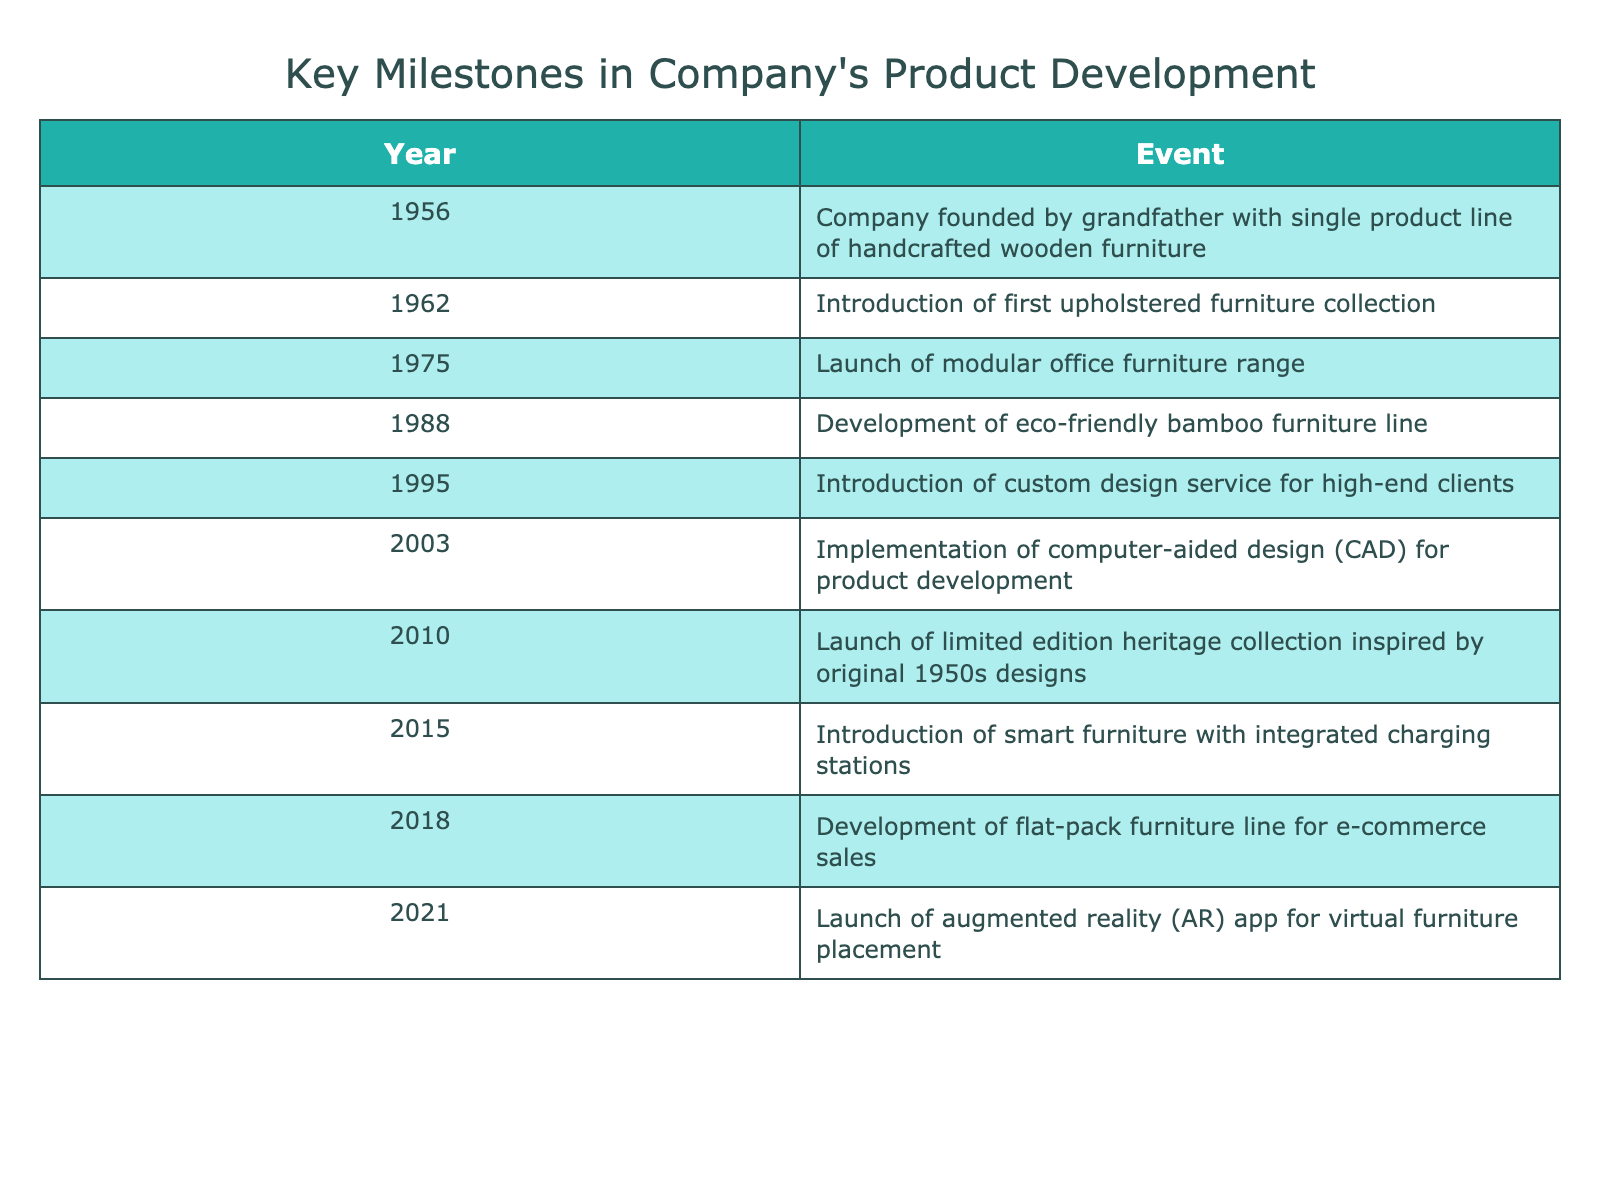What year did the company introduce its first upholstered furniture collection? The table explicitly states that the first upholstered furniture collection was introduced in 1962, as indicated in the "Year" column.
Answer: 1962 How many product lines were launched before the year 2000? The events listed before the year 2000 are: 1956 (founding), 1962 (upholstered collection), 1975 (modular office range), 1988 (bamboo line), 1995 (custom design). This totals to 5 product lines launched before 2000.
Answer: 5 Is the launch of smart furniture in 2015 the first instance of integrating technology in products? The first instance of integrating technology is in 2003 with the implementation of computer-aided design (CAD). Thus, the smart furniture launch is not the first.
Answer: No Which product development event occurred last? The last event in the timeline is the launch of the augmented reality app for virtual furniture placement in 2021, as indicated by the latest year listed in the table.
Answer: 2021 What is the total number of product development milestones listed in the table? By counting all the events from the table, there are a total of 10 milestones from 1956 to 2021.
Answer: 10 What was the primary focus of the product development event in 1988? The 1988 event is focused on the development of an eco-friendly bamboo furniture line, which reflects an emphasis on sustainability and eco-friendliness in furniture design.
Answer: Eco-friendly bamboo furniture Which years saw significant technological advancements in product development? Technological advancements are noted in 2003 with CAD implementation and in 2015 with the introduction of smart furniture. Both events signify a major technological shift and innovation timeline.
Answer: 2003 and 2015 What was the purpose of introducing the custom design service in 1995? The introduction of the custom design service in 1995 catered to high-end clients, allowing them personalized options in furniture design to meet specific customer needs.
Answer: High-end client personalization What is the average gap in years between the major product launches listed in the timeline? To find the average gap: Identify the years and find the difference between each consecutive launch: (1962-1956, 1975-1962, etc.) Summing these differences gives a total of 38 years, and there are 9 gaps. Total gap = 38 years / 9 gaps = approximately 4.22 years; rounding gives us about 4 years.
Answer: About 4 years 